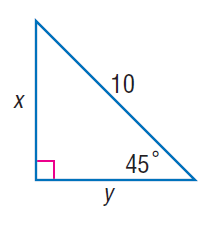Question: Find y.
Choices:
A. 5
B. 5 \sqrt { 2 }
C. 10
D. 10 \sqrt { 2 }
Answer with the letter. Answer: B Question: Find x.
Choices:
A. 5
B. 5 \sqrt { 2 }
C. 10
D. 10 \sqrt { 2 }
Answer with the letter. Answer: B 